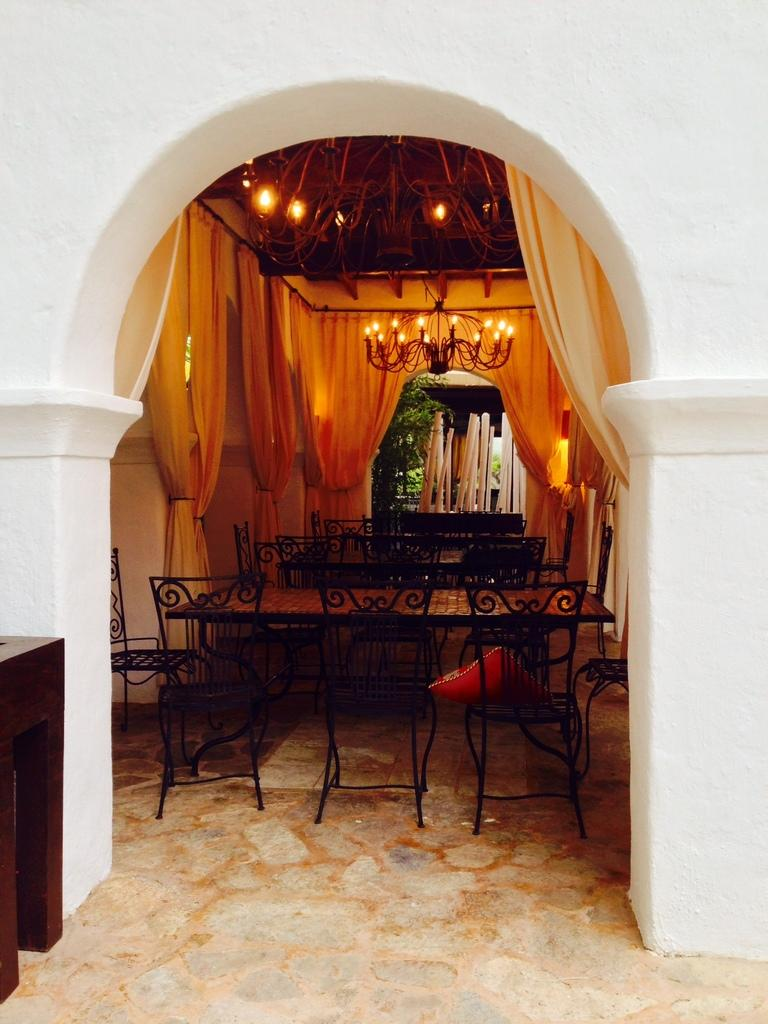What type of furniture is present in the image? There are tables and chairs in the image. What is above the tables and chairs? There are lights above the tables and chairs. What type of window treatment is visible in the image? There are curtains on either side of the scene. What can be seen in the left corner of the image? There is a wooden object in the left corner of the image. What type of cap is the alley wearing in the image? There is no alley or cap present in the image. How much sugar is visible on the tables in the image? There is no sugar visible on the tables in the image. 